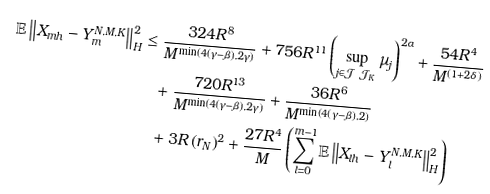Convert formula to latex. <formula><loc_0><loc_0><loc_500><loc_500>\mathbb { E } \left \| X _ { m h } - Y _ { m } ^ { N , M , K } \right \| _ { H } ^ { 2 } & \leq \frac { 3 2 4 R ^ { 8 } } { M ^ { \min \left ( 4 \left ( \gamma - \beta \right ) , 2 \gamma \right ) } } + 7 5 6 R ^ { 1 1 } \left ( \sup _ { j \in \mathcal { J } \ \mathcal { J } _ { K } } \mu _ { j } \right ) ^ { 2 \alpha } + \frac { 5 4 R ^ { 4 } } { M ^ { \left ( 1 + 2 \delta \right ) } } \\ & \quad + \frac { 7 2 0 R ^ { 1 3 } } { M ^ { \min \left ( 4 \left ( \gamma - \beta \right ) , 2 \gamma \right ) } } + \frac { 3 6 R ^ { 6 } } { M ^ { \min \left ( 4 \left ( \gamma - \beta \right ) , 2 \right ) } } \\ & \quad + 3 R \left ( r _ { N } \right ) ^ { 2 } + \frac { 2 7 R ^ { 4 } } { M } \left ( \sum _ { l = 0 } ^ { m - 1 } \mathbb { E } \left \| X _ { l h } - Y _ { l } ^ { N , M , K } \right \| _ { H } ^ { 2 } \right )</formula> 